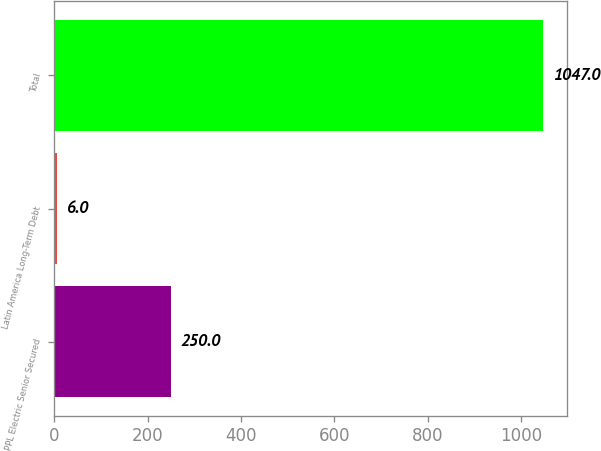<chart> <loc_0><loc_0><loc_500><loc_500><bar_chart><fcel>PPL Electric Senior Secured<fcel>Latin America Long-Term Debt<fcel>Total<nl><fcel>250<fcel>6<fcel>1047<nl></chart> 